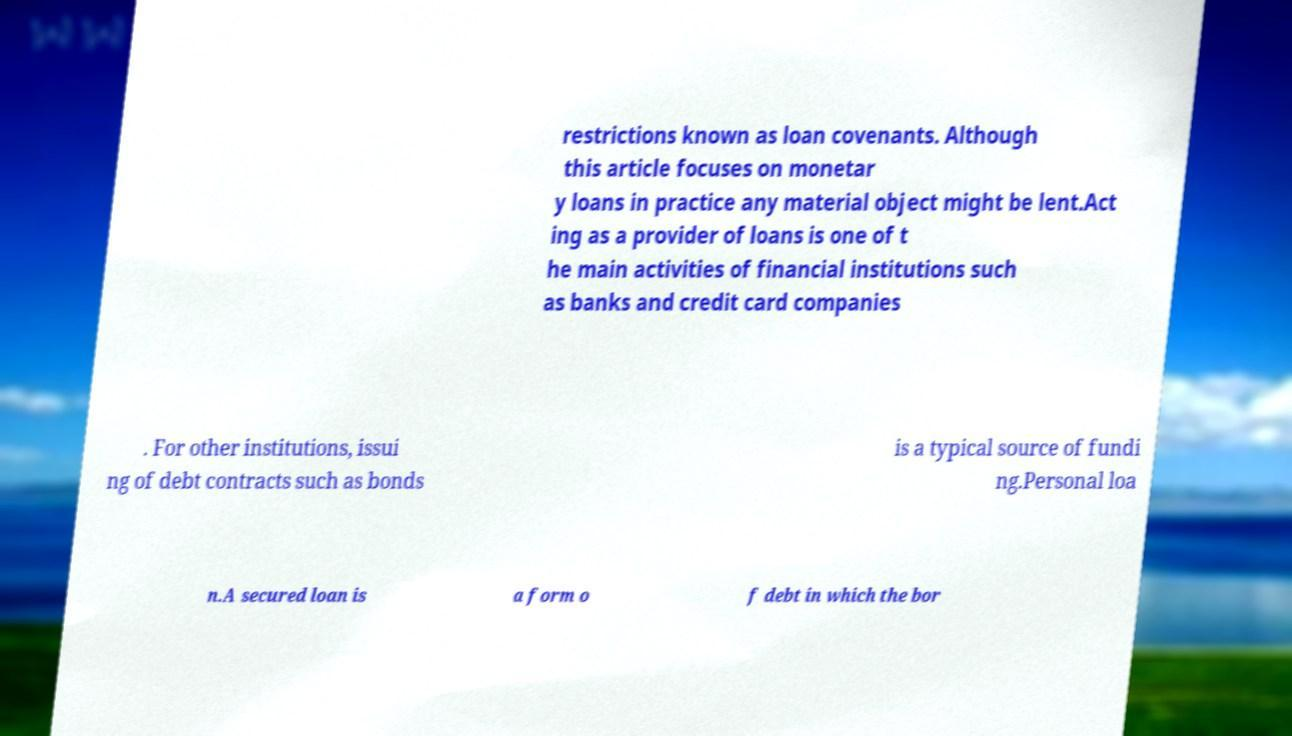Please identify and transcribe the text found in this image. restrictions known as loan covenants. Although this article focuses on monetar y loans in practice any material object might be lent.Act ing as a provider of loans is one of t he main activities of financial institutions such as banks and credit card companies . For other institutions, issui ng of debt contracts such as bonds is a typical source of fundi ng.Personal loa n.A secured loan is a form o f debt in which the bor 